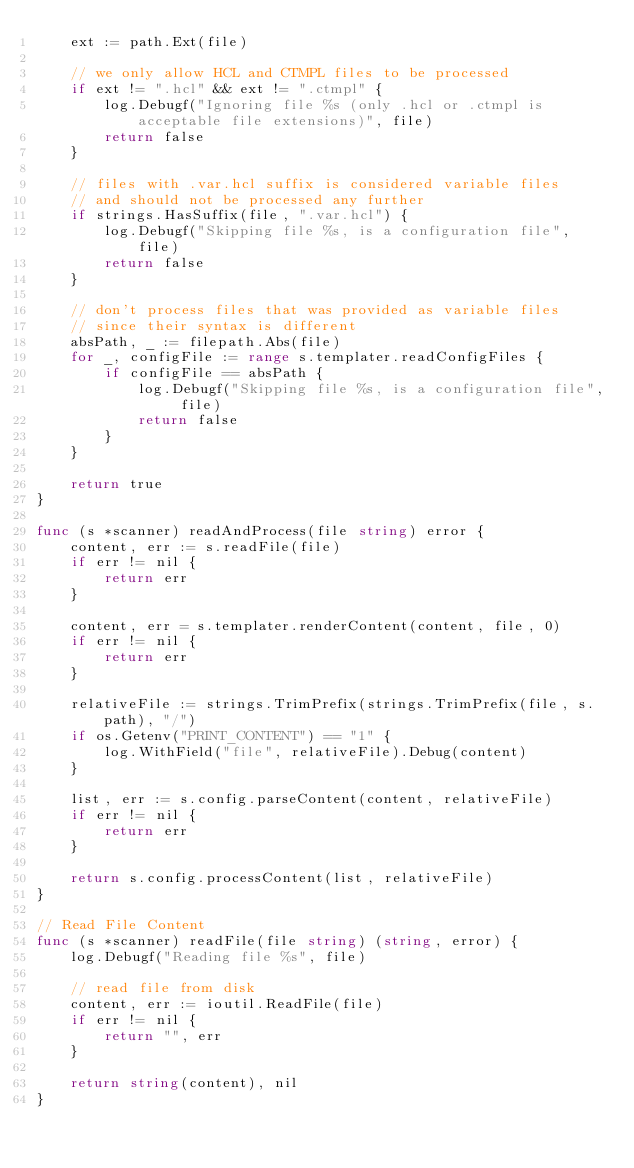Convert code to text. <code><loc_0><loc_0><loc_500><loc_500><_Go_>	ext := path.Ext(file)

	// we only allow HCL and CTMPL files to be processed
	if ext != ".hcl" && ext != ".ctmpl" {
		log.Debugf("Ignoring file %s (only .hcl or .ctmpl is acceptable file extensions)", file)
		return false
	}

	// files with .var.hcl suffix is considered variable files
	// and should not be processed any further
	if strings.HasSuffix(file, ".var.hcl") {
		log.Debugf("Skipping file %s, is a configuration file", file)
		return false
	}

	// don't process files that was provided as variable files
	// since their syntax is different
	absPath, _ := filepath.Abs(file)
	for _, configFile := range s.templater.readConfigFiles {
		if configFile == absPath {
			log.Debugf("Skipping file %s, is a configuration file", file)
			return false
		}
	}

	return true
}

func (s *scanner) readAndProcess(file string) error {
	content, err := s.readFile(file)
	if err != nil {
		return err
	}

	content, err = s.templater.renderContent(content, file, 0)
	if err != nil {
		return err
	}

	relativeFile := strings.TrimPrefix(strings.TrimPrefix(file, s.path), "/")
	if os.Getenv("PRINT_CONTENT") == "1" {
		log.WithField("file", relativeFile).Debug(content)
	}

	list, err := s.config.parseContent(content, relativeFile)
	if err != nil {
		return err
	}

	return s.config.processContent(list, relativeFile)
}

// Read File Content
func (s *scanner) readFile(file string) (string, error) {
	log.Debugf("Reading file %s", file)

	// read file from disk
	content, err := ioutil.ReadFile(file)
	if err != nil {
		return "", err
	}

	return string(content), nil
}
</code> 